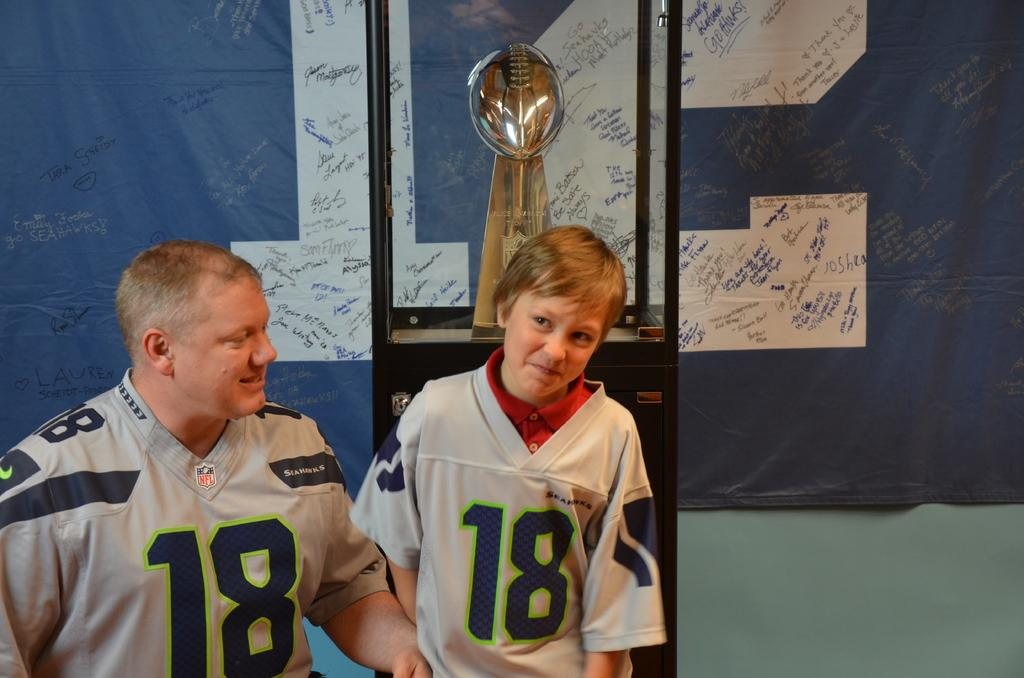<image>
Present a compact description of the photo's key features. Two people in number 18 jerseys next to a replica Super Bowl trophy. 